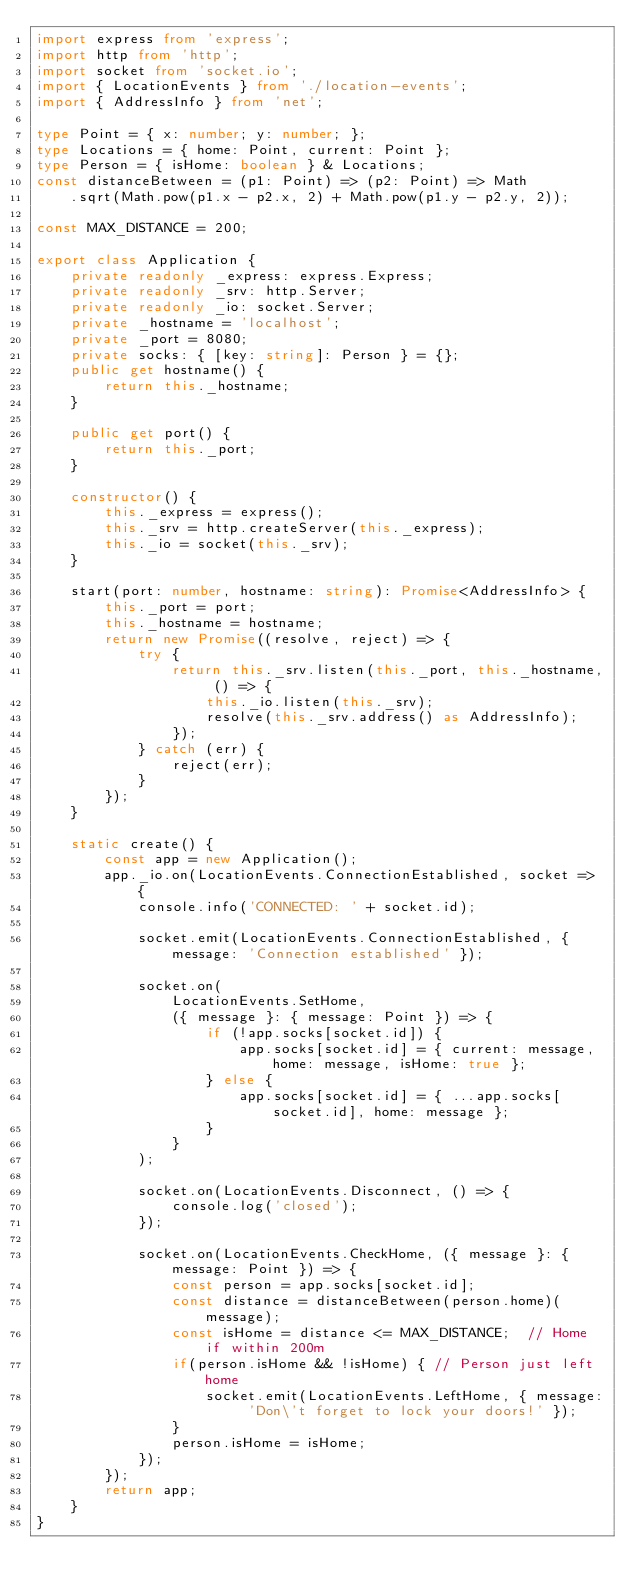Convert code to text. <code><loc_0><loc_0><loc_500><loc_500><_TypeScript_>import express from 'express';
import http from 'http';
import socket from 'socket.io';
import { LocationEvents } from './location-events';
import { AddressInfo } from 'net';

type Point = { x: number; y: number; };
type Locations = { home: Point, current: Point };
type Person = { isHome: boolean } & Locations;
const distanceBetween = (p1: Point) => (p2: Point) => Math
    .sqrt(Math.pow(p1.x - p2.x, 2) + Math.pow(p1.y - p2.y, 2));

const MAX_DISTANCE = 200;

export class Application {
    private readonly _express: express.Express;
    private readonly _srv: http.Server;
    private readonly _io: socket.Server;
    private _hostname = 'localhost';
    private _port = 8080;
    private socks: { [key: string]: Person } = {};
    public get hostname() {
        return this._hostname;
    }

    public get port() {
        return this._port;
    }

    constructor() {
        this._express = express();
        this._srv = http.createServer(this._express);
        this._io = socket(this._srv);
    }

    start(port: number, hostname: string): Promise<AddressInfo> {
        this._port = port;
        this._hostname = hostname;
        return new Promise((resolve, reject) => {
            try {
                return this._srv.listen(this._port, this._hostname, () => {
                    this._io.listen(this._srv);
                    resolve(this._srv.address() as AddressInfo);
                });
            } catch (err) {
                reject(err);
            }
        });
    }

    static create() {
        const app = new Application();
        app._io.on(LocationEvents.ConnectionEstablished, socket => {
            console.info('CONNECTED: ' + socket.id);

            socket.emit(LocationEvents.ConnectionEstablished, { message: 'Connection established' });

            socket.on(
                LocationEvents.SetHome,
                ({ message }: { message: Point }) => {
                    if (!app.socks[socket.id]) {
                        app.socks[socket.id] = { current: message, home: message, isHome: true };
                    } else {
                        app.socks[socket.id] = { ...app.socks[socket.id], home: message };
                    }
                }
            );

            socket.on(LocationEvents.Disconnect, () => {
                console.log('closed');
            });

            socket.on(LocationEvents.CheckHome, ({ message }: { message: Point }) => {
                const person = app.socks[socket.id];
                const distance = distanceBetween(person.home)(message);
                const isHome = distance <= MAX_DISTANCE;  // Home if within 200m
                if(person.isHome && !isHome) { // Person just left home
                    socket.emit(LocationEvents.LeftHome, { message: 'Don\'t forget to lock your doors!' });
                }
                person.isHome = isHome;
            });
        });
        return app;
    }
}
</code> 